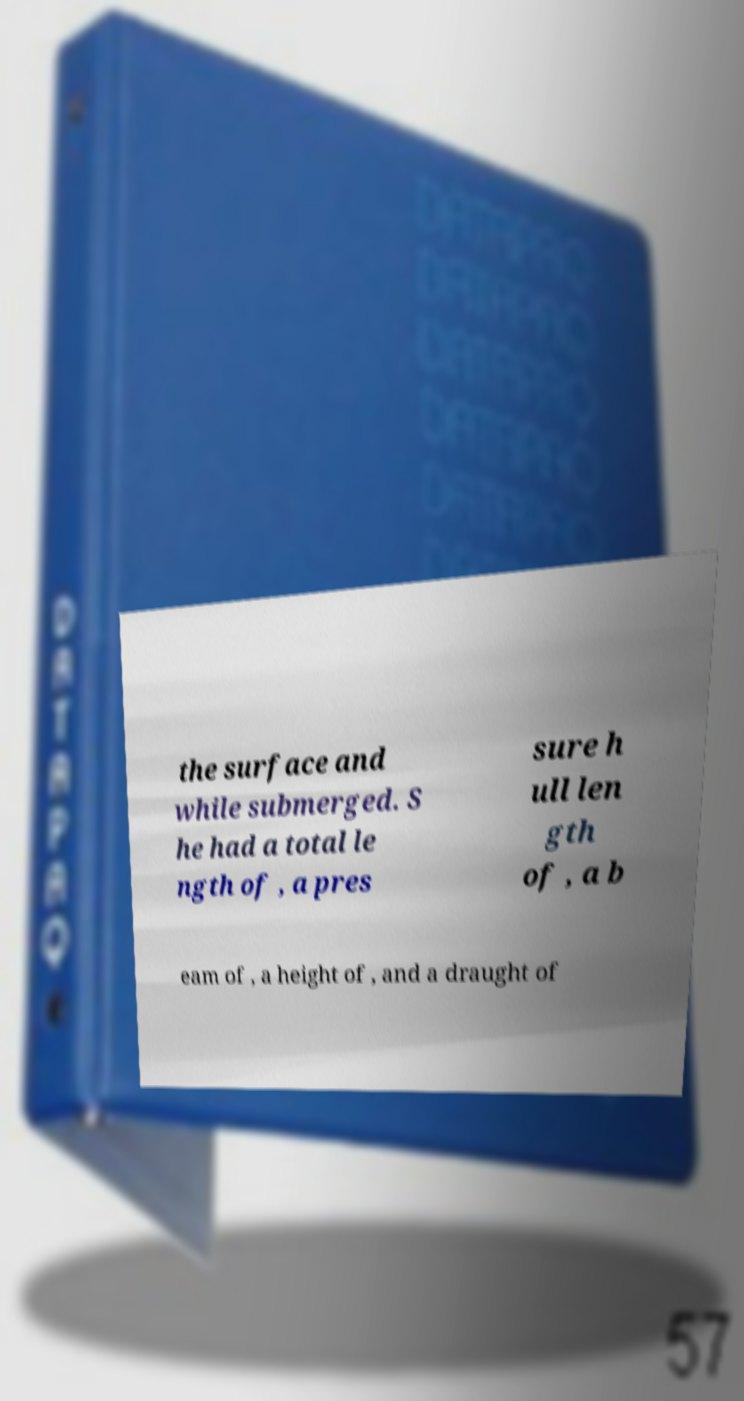Can you accurately transcribe the text from the provided image for me? the surface and while submerged. S he had a total le ngth of , a pres sure h ull len gth of , a b eam of , a height of , and a draught of 